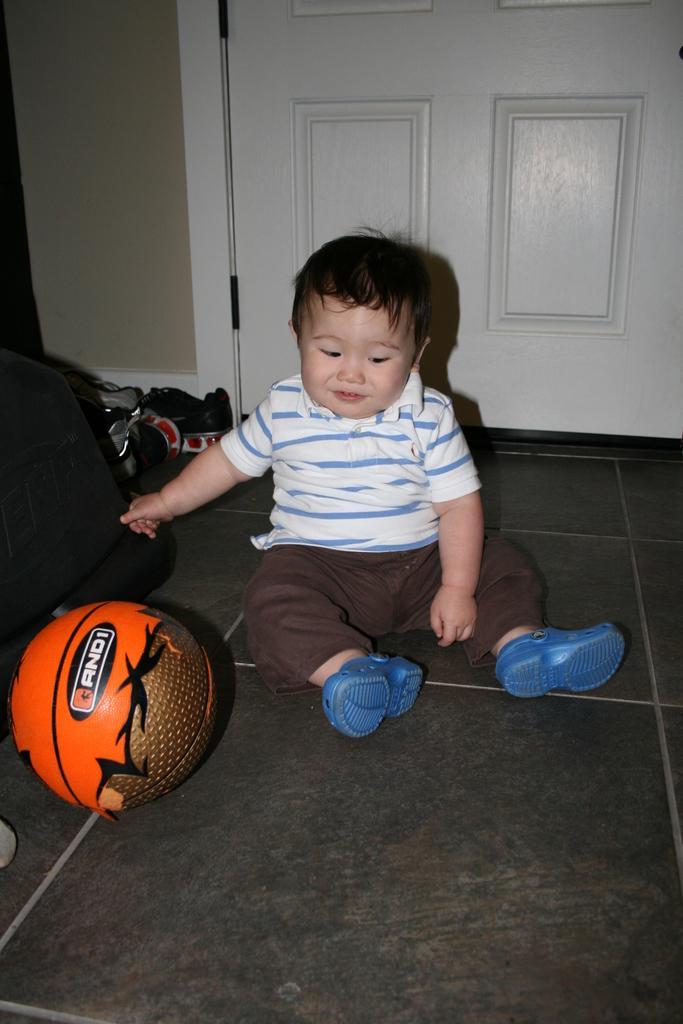Describe this image in one or two sentences. In this image there is a kid sitting on the floor. To the left there are a few objects and a ball. The kid is touching an object. Behind the kid there is a door to the wall. 